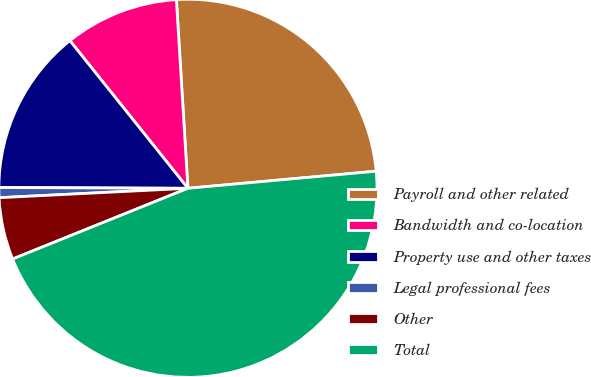<chart> <loc_0><loc_0><loc_500><loc_500><pie_chart><fcel>Payroll and other related<fcel>Bandwidth and co-location<fcel>Property use and other taxes<fcel>Legal professional fees<fcel>Other<fcel>Total<nl><fcel>24.53%<fcel>9.76%<fcel>14.2%<fcel>0.86%<fcel>5.31%<fcel>45.34%<nl></chart> 